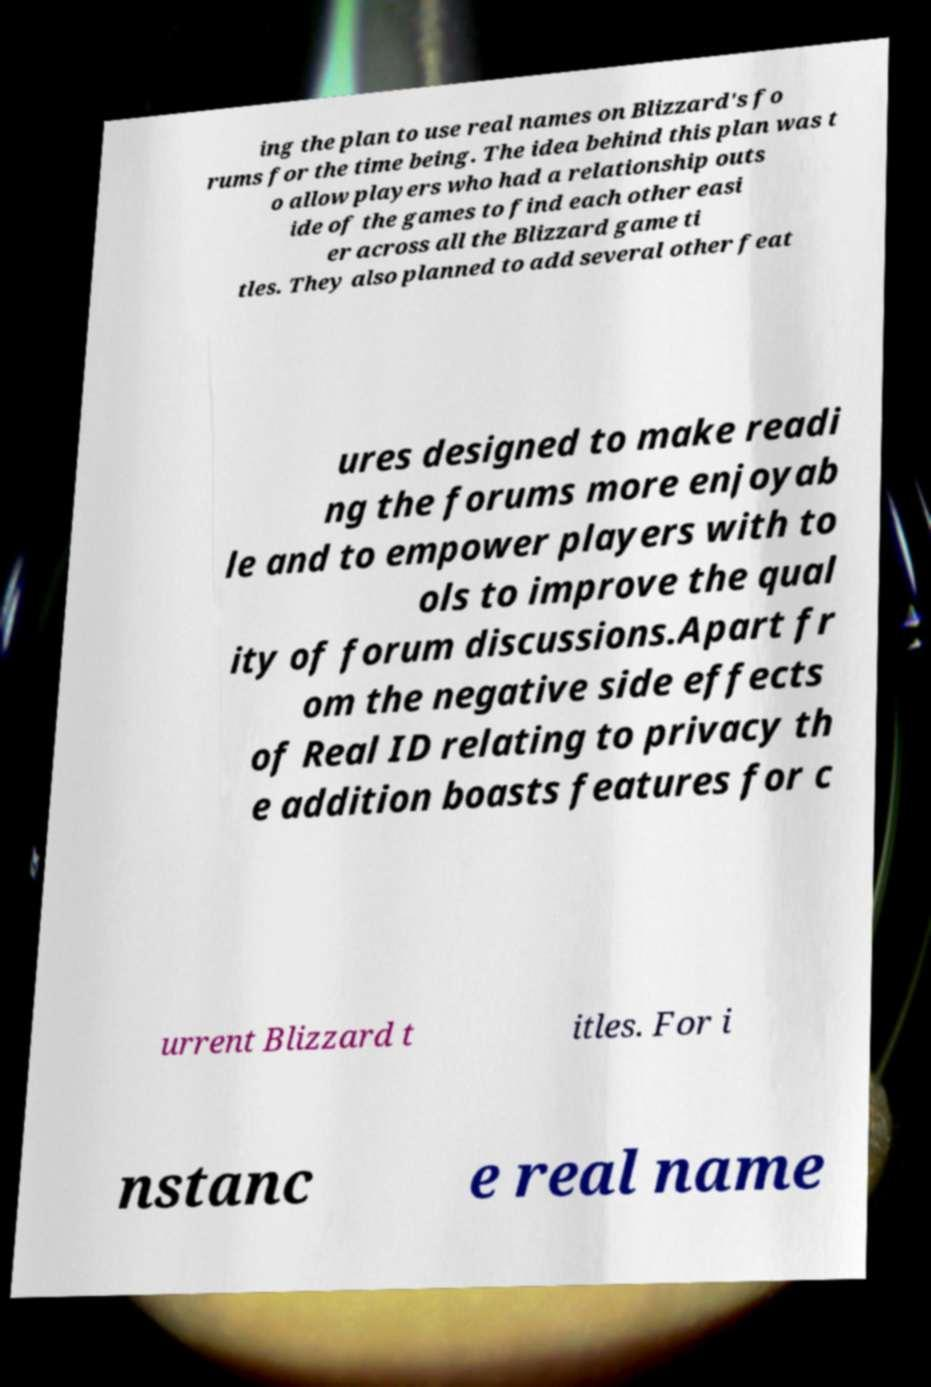What messages or text are displayed in this image? I need them in a readable, typed format. ing the plan to use real names on Blizzard's fo rums for the time being. The idea behind this plan was t o allow players who had a relationship outs ide of the games to find each other easi er across all the Blizzard game ti tles. They also planned to add several other feat ures designed to make readi ng the forums more enjoyab le and to empower players with to ols to improve the qual ity of forum discussions.Apart fr om the negative side effects of Real ID relating to privacy th e addition boasts features for c urrent Blizzard t itles. For i nstanc e real name 